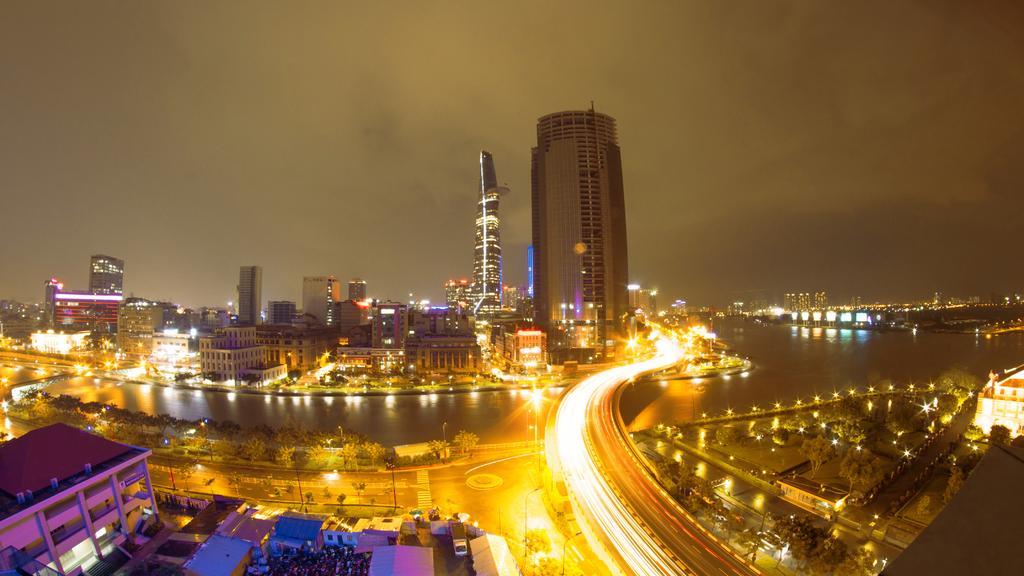Describe this image in one or two sentences. In this image we can see buildings, lights, towers, water and other objects. On the right side of the image there are trees, lights, building, road and other objects. At the bottom of the image there is a road, vehicle, trees and other objects. On the left side of the image there is a building, trees, water and other objects. At the top of the image there is the sky. 